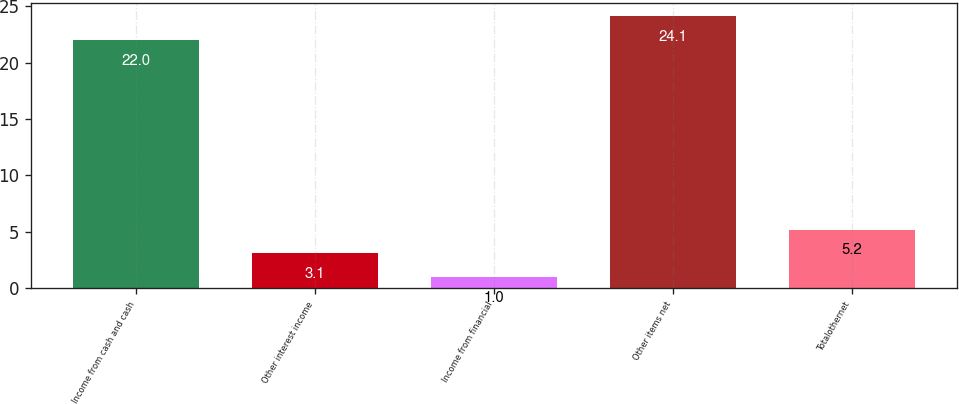Convert chart to OTSL. <chart><loc_0><loc_0><loc_500><loc_500><bar_chart><fcel>Income from cash and cash<fcel>Other interest income<fcel>Income from financial<fcel>Other items net<fcel>Totalothernet<nl><fcel>22<fcel>3.1<fcel>1<fcel>24.1<fcel>5.2<nl></chart> 